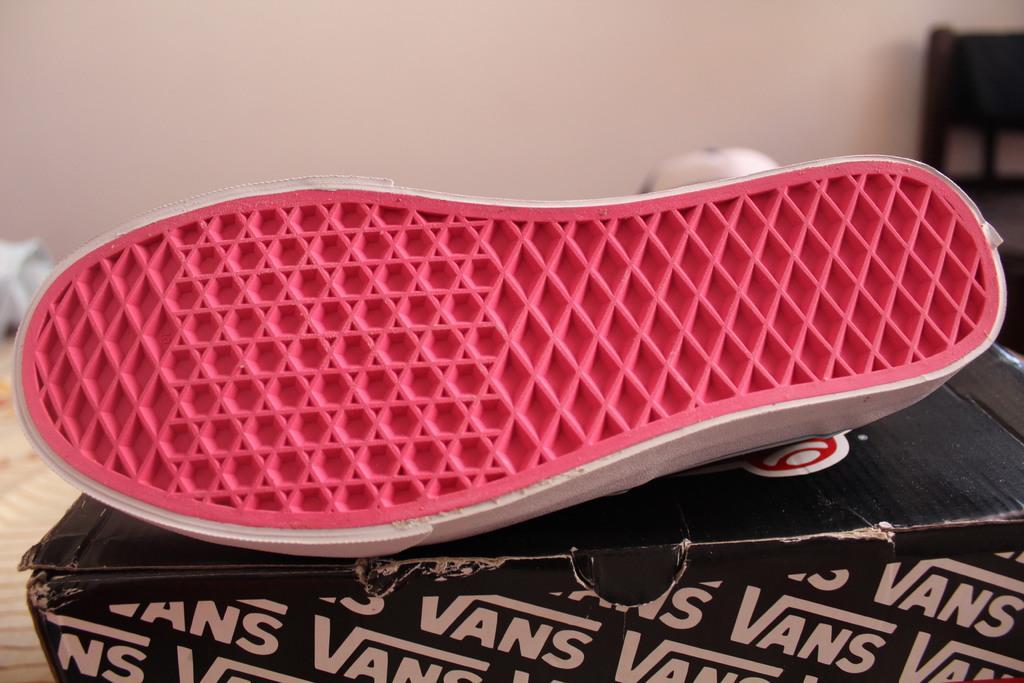How would you summarize this image in a sentence or two? In the center of the image we can see shoe placed on the box. In the background there is wall and chair. 